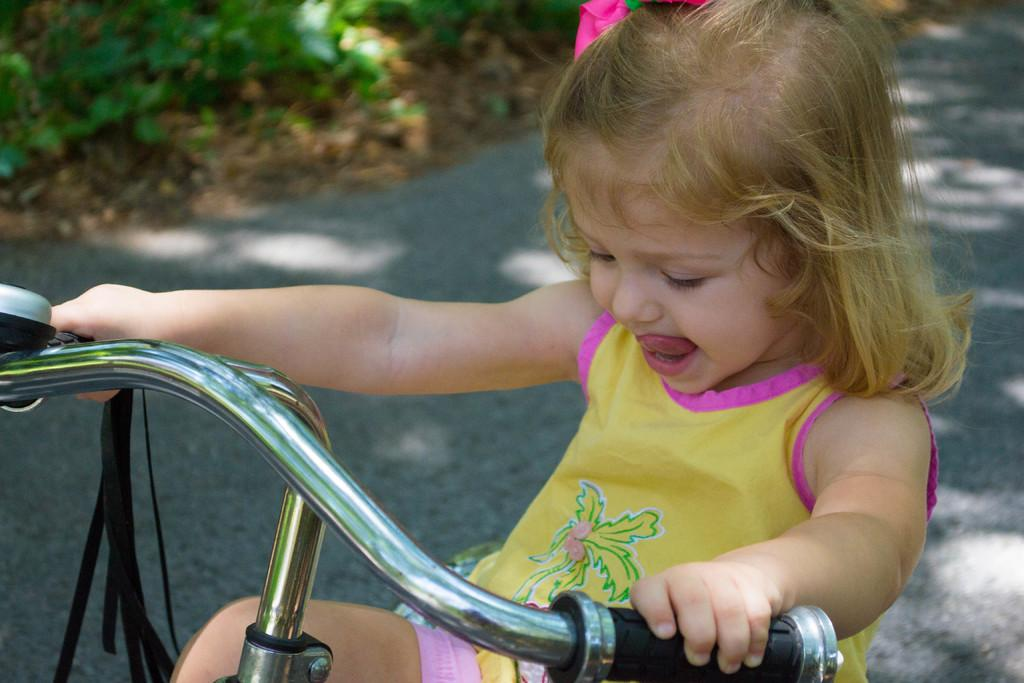What is the person in the image doing? The person is riding a bicycle. Where is the bicycle located? The bicycle is on the road. What can be seen in the background of the image? There are plants visible in the image. What type of reaction does the lawyer have when they see the person working on the bicycle in the image? There is no lawyer or indication of work present in the image, so it is not possible to determine any reactions. 